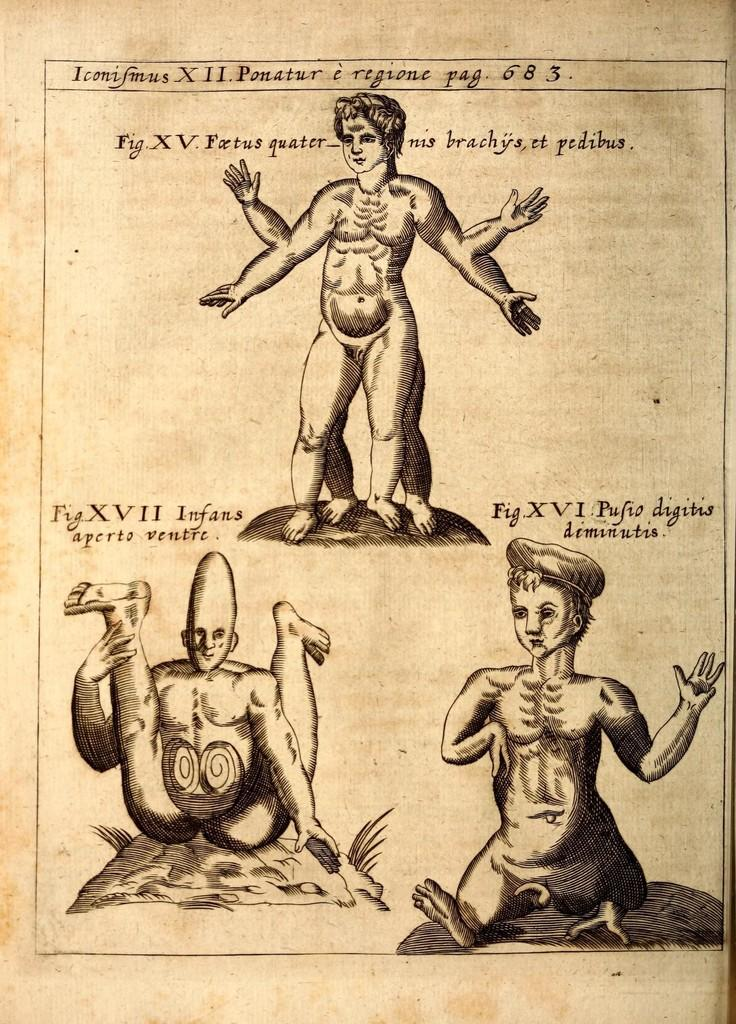What is the main subject of the image? The main subject of the image is a magazine paper. What are the people in the image doing? There are three people drawing on the magazine paper. What additional information can be found on the magazine paper? There is some information about the people on the magazine paper. What type of meat is being cooked by the group in the image? There is no group or meat present in the image; it features a magazine paper with people drawing on it. 